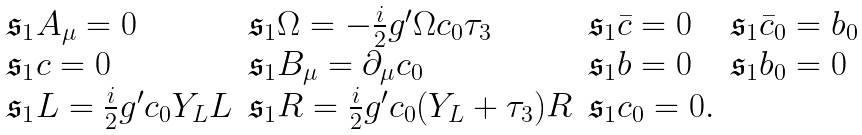Convert formula to latex. <formula><loc_0><loc_0><loc_500><loc_500>\begin{array} { l l l l } \mathfrak { s } _ { 1 } A _ { \mu } = 0 & \mathfrak { s } _ { 1 } \Omega = - \frac { i } { 2 } g ^ { \prime } \Omega c _ { 0 } \tau _ { 3 } & \mathfrak { s } _ { 1 } \bar { c } = 0 & \mathfrak { s } _ { 1 } \bar { c } _ { 0 } = b _ { 0 } \\ \mathfrak { s } _ { 1 } c = 0 & \mathfrak { s } _ { 1 } B _ { \mu } = \partial _ { \mu } c _ { 0 } & \mathfrak { s } _ { 1 } b = 0 & \mathfrak { s } _ { 1 } b _ { 0 } = 0 \\ \mathfrak { s } _ { 1 } L = \frac { i } { 2 } g ^ { \prime } c _ { 0 } Y _ { L } L & \mathfrak { s } _ { 1 } R = \frac { i } { 2 } g ^ { \prime } c _ { 0 } ( Y _ { L } + \tau _ { 3 } ) R & \mathfrak { s } _ { 1 } c _ { 0 } = 0 . & \end{array}</formula> 